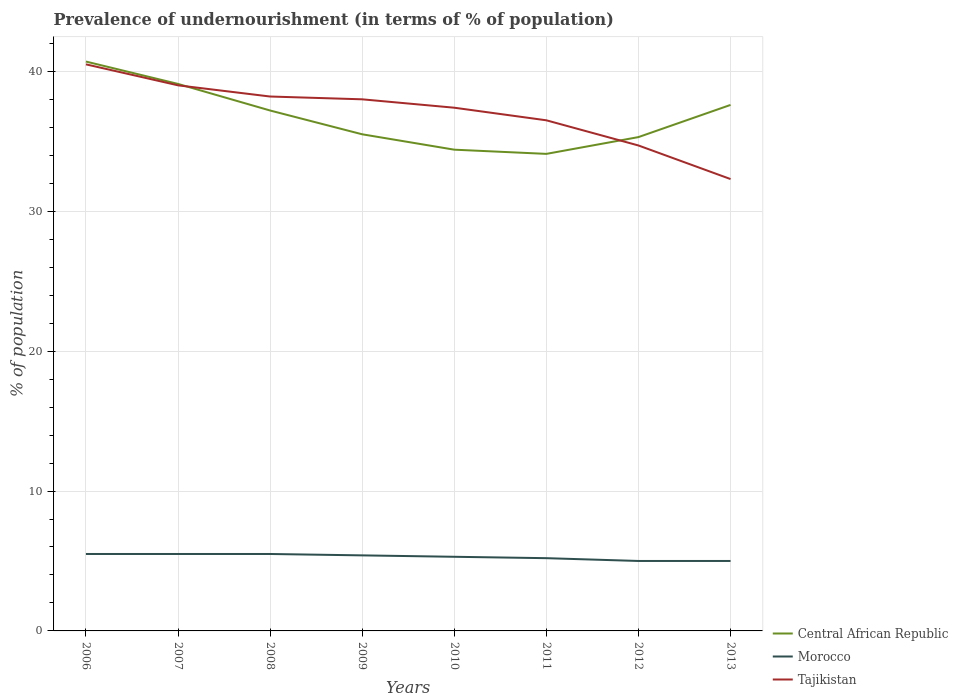What is the total percentage of undernourished population in Tajikistan in the graph?
Your response must be concise. 2.5. What is the difference between the highest and the second highest percentage of undernourished population in Central African Republic?
Offer a terse response. 6.6. What is the difference between the highest and the lowest percentage of undernourished population in Central African Republic?
Your response must be concise. 4. How many lines are there?
Provide a succinct answer. 3. How many years are there in the graph?
Offer a very short reply. 8. Are the values on the major ticks of Y-axis written in scientific E-notation?
Give a very brief answer. No. Where does the legend appear in the graph?
Offer a terse response. Bottom right. How many legend labels are there?
Your response must be concise. 3. How are the legend labels stacked?
Ensure brevity in your answer.  Vertical. What is the title of the graph?
Your answer should be compact. Prevalence of undernourishment (in terms of % of population). Does "Sudan" appear as one of the legend labels in the graph?
Your answer should be compact. No. What is the label or title of the X-axis?
Your answer should be compact. Years. What is the label or title of the Y-axis?
Your answer should be very brief. % of population. What is the % of population of Central African Republic in 2006?
Offer a terse response. 40.7. What is the % of population of Morocco in 2006?
Your answer should be very brief. 5.5. What is the % of population in Tajikistan in 2006?
Offer a terse response. 40.5. What is the % of population of Central African Republic in 2007?
Provide a succinct answer. 39.1. What is the % of population of Morocco in 2007?
Offer a very short reply. 5.5. What is the % of population in Tajikistan in 2007?
Give a very brief answer. 39. What is the % of population in Central African Republic in 2008?
Ensure brevity in your answer.  37.2. What is the % of population of Morocco in 2008?
Offer a very short reply. 5.5. What is the % of population in Tajikistan in 2008?
Make the answer very short. 38.2. What is the % of population in Central African Republic in 2009?
Your response must be concise. 35.5. What is the % of population of Morocco in 2009?
Keep it short and to the point. 5.4. What is the % of population of Central African Republic in 2010?
Keep it short and to the point. 34.4. What is the % of population in Tajikistan in 2010?
Your response must be concise. 37.4. What is the % of population of Central African Republic in 2011?
Provide a succinct answer. 34.1. What is the % of population of Tajikistan in 2011?
Your answer should be compact. 36.5. What is the % of population in Central African Republic in 2012?
Ensure brevity in your answer.  35.3. What is the % of population in Morocco in 2012?
Your response must be concise. 5. What is the % of population in Tajikistan in 2012?
Ensure brevity in your answer.  34.7. What is the % of population of Central African Republic in 2013?
Your answer should be compact. 37.6. What is the % of population of Morocco in 2013?
Your answer should be compact. 5. What is the % of population in Tajikistan in 2013?
Ensure brevity in your answer.  32.3. Across all years, what is the maximum % of population in Central African Republic?
Make the answer very short. 40.7. Across all years, what is the maximum % of population in Morocco?
Give a very brief answer. 5.5. Across all years, what is the maximum % of population in Tajikistan?
Your answer should be very brief. 40.5. Across all years, what is the minimum % of population of Central African Republic?
Keep it short and to the point. 34.1. Across all years, what is the minimum % of population of Morocco?
Offer a terse response. 5. Across all years, what is the minimum % of population in Tajikistan?
Provide a short and direct response. 32.3. What is the total % of population in Central African Republic in the graph?
Provide a succinct answer. 293.9. What is the total % of population of Morocco in the graph?
Give a very brief answer. 42.4. What is the total % of population of Tajikistan in the graph?
Provide a short and direct response. 296.6. What is the difference between the % of population in Central African Republic in 2006 and that in 2007?
Your answer should be very brief. 1.6. What is the difference between the % of population of Central African Republic in 2006 and that in 2008?
Provide a short and direct response. 3.5. What is the difference between the % of population of Morocco in 2006 and that in 2008?
Offer a terse response. 0. What is the difference between the % of population in Tajikistan in 2006 and that in 2008?
Ensure brevity in your answer.  2.3. What is the difference between the % of population of Morocco in 2006 and that in 2010?
Ensure brevity in your answer.  0.2. What is the difference between the % of population of Central African Republic in 2006 and that in 2011?
Provide a short and direct response. 6.6. What is the difference between the % of population of Morocco in 2006 and that in 2011?
Keep it short and to the point. 0.3. What is the difference between the % of population in Tajikistan in 2006 and that in 2011?
Provide a succinct answer. 4. What is the difference between the % of population in Central African Republic in 2006 and that in 2012?
Your answer should be very brief. 5.4. What is the difference between the % of population of Tajikistan in 2006 and that in 2012?
Your response must be concise. 5.8. What is the difference between the % of population in Morocco in 2006 and that in 2013?
Keep it short and to the point. 0.5. What is the difference between the % of population of Tajikistan in 2006 and that in 2013?
Ensure brevity in your answer.  8.2. What is the difference between the % of population of Central African Republic in 2007 and that in 2008?
Give a very brief answer. 1.9. What is the difference between the % of population in Morocco in 2007 and that in 2008?
Make the answer very short. 0. What is the difference between the % of population of Tajikistan in 2007 and that in 2008?
Ensure brevity in your answer.  0.8. What is the difference between the % of population in Central African Republic in 2007 and that in 2009?
Offer a very short reply. 3.6. What is the difference between the % of population of Morocco in 2007 and that in 2009?
Keep it short and to the point. 0.1. What is the difference between the % of population of Tajikistan in 2007 and that in 2009?
Your answer should be very brief. 1. What is the difference between the % of population of Morocco in 2007 and that in 2010?
Ensure brevity in your answer.  0.2. What is the difference between the % of population of Tajikistan in 2007 and that in 2010?
Your answer should be very brief. 1.6. What is the difference between the % of population of Central African Republic in 2007 and that in 2012?
Your answer should be very brief. 3.8. What is the difference between the % of population of Tajikistan in 2007 and that in 2013?
Ensure brevity in your answer.  6.7. What is the difference between the % of population of Central African Republic in 2008 and that in 2009?
Ensure brevity in your answer.  1.7. What is the difference between the % of population of Tajikistan in 2008 and that in 2009?
Your response must be concise. 0.2. What is the difference between the % of population in Central African Republic in 2008 and that in 2010?
Offer a terse response. 2.8. What is the difference between the % of population of Morocco in 2008 and that in 2010?
Offer a very short reply. 0.2. What is the difference between the % of population of Tajikistan in 2008 and that in 2011?
Your answer should be compact. 1.7. What is the difference between the % of population in Central African Republic in 2008 and that in 2012?
Your answer should be compact. 1.9. What is the difference between the % of population in Morocco in 2008 and that in 2012?
Your answer should be very brief. 0.5. What is the difference between the % of population of Central African Republic in 2009 and that in 2010?
Your answer should be very brief. 1.1. What is the difference between the % of population of Tajikistan in 2009 and that in 2010?
Offer a very short reply. 0.6. What is the difference between the % of population in Central African Republic in 2009 and that in 2011?
Provide a succinct answer. 1.4. What is the difference between the % of population of Morocco in 2009 and that in 2011?
Provide a succinct answer. 0.2. What is the difference between the % of population of Tajikistan in 2009 and that in 2011?
Provide a short and direct response. 1.5. What is the difference between the % of population of Morocco in 2009 and that in 2013?
Offer a terse response. 0.4. What is the difference between the % of population in Tajikistan in 2009 and that in 2013?
Your answer should be compact. 5.7. What is the difference between the % of population of Central African Republic in 2010 and that in 2012?
Give a very brief answer. -0.9. What is the difference between the % of population in Morocco in 2010 and that in 2012?
Make the answer very short. 0.3. What is the difference between the % of population in Central African Republic in 2010 and that in 2013?
Your response must be concise. -3.2. What is the difference between the % of population of Tajikistan in 2010 and that in 2013?
Your answer should be compact. 5.1. What is the difference between the % of population of Central African Republic in 2011 and that in 2012?
Keep it short and to the point. -1.2. What is the difference between the % of population of Central African Republic in 2011 and that in 2013?
Your answer should be compact. -3.5. What is the difference between the % of population of Morocco in 2011 and that in 2013?
Your response must be concise. 0.2. What is the difference between the % of population in Tajikistan in 2011 and that in 2013?
Your response must be concise. 4.2. What is the difference between the % of population of Central African Republic in 2012 and that in 2013?
Your response must be concise. -2.3. What is the difference between the % of population in Morocco in 2012 and that in 2013?
Give a very brief answer. 0. What is the difference between the % of population in Central African Republic in 2006 and the % of population in Morocco in 2007?
Provide a short and direct response. 35.2. What is the difference between the % of population of Central African Republic in 2006 and the % of population of Tajikistan in 2007?
Offer a terse response. 1.7. What is the difference between the % of population in Morocco in 2006 and the % of population in Tajikistan in 2007?
Offer a very short reply. -33.5. What is the difference between the % of population in Central African Republic in 2006 and the % of population in Morocco in 2008?
Provide a short and direct response. 35.2. What is the difference between the % of population of Morocco in 2006 and the % of population of Tajikistan in 2008?
Ensure brevity in your answer.  -32.7. What is the difference between the % of population of Central African Republic in 2006 and the % of population of Morocco in 2009?
Your answer should be compact. 35.3. What is the difference between the % of population of Central African Republic in 2006 and the % of population of Tajikistan in 2009?
Offer a very short reply. 2.7. What is the difference between the % of population of Morocco in 2006 and the % of population of Tajikistan in 2009?
Make the answer very short. -32.5. What is the difference between the % of population in Central African Republic in 2006 and the % of population in Morocco in 2010?
Your answer should be very brief. 35.4. What is the difference between the % of population of Central African Republic in 2006 and the % of population of Tajikistan in 2010?
Make the answer very short. 3.3. What is the difference between the % of population in Morocco in 2006 and the % of population in Tajikistan in 2010?
Keep it short and to the point. -31.9. What is the difference between the % of population in Central African Republic in 2006 and the % of population in Morocco in 2011?
Your answer should be compact. 35.5. What is the difference between the % of population in Morocco in 2006 and the % of population in Tajikistan in 2011?
Offer a terse response. -31. What is the difference between the % of population in Central African Republic in 2006 and the % of population in Morocco in 2012?
Your answer should be compact. 35.7. What is the difference between the % of population of Morocco in 2006 and the % of population of Tajikistan in 2012?
Provide a short and direct response. -29.2. What is the difference between the % of population of Central African Republic in 2006 and the % of population of Morocco in 2013?
Ensure brevity in your answer.  35.7. What is the difference between the % of population of Central African Republic in 2006 and the % of population of Tajikistan in 2013?
Offer a very short reply. 8.4. What is the difference between the % of population in Morocco in 2006 and the % of population in Tajikistan in 2013?
Offer a terse response. -26.8. What is the difference between the % of population of Central African Republic in 2007 and the % of population of Morocco in 2008?
Keep it short and to the point. 33.6. What is the difference between the % of population of Morocco in 2007 and the % of population of Tajikistan in 2008?
Provide a succinct answer. -32.7. What is the difference between the % of population in Central African Republic in 2007 and the % of population in Morocco in 2009?
Offer a very short reply. 33.7. What is the difference between the % of population in Central African Republic in 2007 and the % of population in Tajikistan in 2009?
Offer a very short reply. 1.1. What is the difference between the % of population of Morocco in 2007 and the % of population of Tajikistan in 2009?
Provide a succinct answer. -32.5. What is the difference between the % of population in Central African Republic in 2007 and the % of population in Morocco in 2010?
Your answer should be compact. 33.8. What is the difference between the % of population of Central African Republic in 2007 and the % of population of Tajikistan in 2010?
Provide a succinct answer. 1.7. What is the difference between the % of population of Morocco in 2007 and the % of population of Tajikistan in 2010?
Give a very brief answer. -31.9. What is the difference between the % of population of Central African Republic in 2007 and the % of population of Morocco in 2011?
Your answer should be compact. 33.9. What is the difference between the % of population of Central African Republic in 2007 and the % of population of Tajikistan in 2011?
Offer a very short reply. 2.6. What is the difference between the % of population of Morocco in 2007 and the % of population of Tajikistan in 2011?
Provide a succinct answer. -31. What is the difference between the % of population in Central African Republic in 2007 and the % of population in Morocco in 2012?
Provide a succinct answer. 34.1. What is the difference between the % of population in Morocco in 2007 and the % of population in Tajikistan in 2012?
Give a very brief answer. -29.2. What is the difference between the % of population of Central African Republic in 2007 and the % of population of Morocco in 2013?
Your answer should be compact. 34.1. What is the difference between the % of population in Central African Republic in 2007 and the % of population in Tajikistan in 2013?
Provide a short and direct response. 6.8. What is the difference between the % of population in Morocco in 2007 and the % of population in Tajikistan in 2013?
Your answer should be very brief. -26.8. What is the difference between the % of population in Central African Republic in 2008 and the % of population in Morocco in 2009?
Your answer should be compact. 31.8. What is the difference between the % of population of Central African Republic in 2008 and the % of population of Tajikistan in 2009?
Provide a short and direct response. -0.8. What is the difference between the % of population of Morocco in 2008 and the % of population of Tajikistan in 2009?
Give a very brief answer. -32.5. What is the difference between the % of population of Central African Republic in 2008 and the % of population of Morocco in 2010?
Offer a very short reply. 31.9. What is the difference between the % of population in Central African Republic in 2008 and the % of population in Tajikistan in 2010?
Give a very brief answer. -0.2. What is the difference between the % of population of Morocco in 2008 and the % of population of Tajikistan in 2010?
Ensure brevity in your answer.  -31.9. What is the difference between the % of population in Morocco in 2008 and the % of population in Tajikistan in 2011?
Provide a short and direct response. -31. What is the difference between the % of population in Central African Republic in 2008 and the % of population in Morocco in 2012?
Keep it short and to the point. 32.2. What is the difference between the % of population in Central African Republic in 2008 and the % of population in Tajikistan in 2012?
Offer a very short reply. 2.5. What is the difference between the % of population in Morocco in 2008 and the % of population in Tajikistan in 2012?
Provide a short and direct response. -29.2. What is the difference between the % of population in Central African Republic in 2008 and the % of population in Morocco in 2013?
Your answer should be very brief. 32.2. What is the difference between the % of population in Morocco in 2008 and the % of population in Tajikistan in 2013?
Give a very brief answer. -26.8. What is the difference between the % of population in Central African Republic in 2009 and the % of population in Morocco in 2010?
Offer a terse response. 30.2. What is the difference between the % of population in Central African Republic in 2009 and the % of population in Tajikistan in 2010?
Offer a terse response. -1.9. What is the difference between the % of population of Morocco in 2009 and the % of population of Tajikistan in 2010?
Your answer should be very brief. -32. What is the difference between the % of population of Central African Republic in 2009 and the % of population of Morocco in 2011?
Your answer should be very brief. 30.3. What is the difference between the % of population in Morocco in 2009 and the % of population in Tajikistan in 2011?
Provide a succinct answer. -31.1. What is the difference between the % of population in Central African Republic in 2009 and the % of population in Morocco in 2012?
Keep it short and to the point. 30.5. What is the difference between the % of population of Morocco in 2009 and the % of population of Tajikistan in 2012?
Your answer should be very brief. -29.3. What is the difference between the % of population of Central African Republic in 2009 and the % of population of Morocco in 2013?
Your response must be concise. 30.5. What is the difference between the % of population in Morocco in 2009 and the % of population in Tajikistan in 2013?
Your answer should be very brief. -26.9. What is the difference between the % of population in Central African Republic in 2010 and the % of population in Morocco in 2011?
Ensure brevity in your answer.  29.2. What is the difference between the % of population in Morocco in 2010 and the % of population in Tajikistan in 2011?
Keep it short and to the point. -31.2. What is the difference between the % of population in Central African Republic in 2010 and the % of population in Morocco in 2012?
Provide a short and direct response. 29.4. What is the difference between the % of population in Central African Republic in 2010 and the % of population in Tajikistan in 2012?
Make the answer very short. -0.3. What is the difference between the % of population of Morocco in 2010 and the % of population of Tajikistan in 2012?
Give a very brief answer. -29.4. What is the difference between the % of population of Central African Republic in 2010 and the % of population of Morocco in 2013?
Your answer should be compact. 29.4. What is the difference between the % of population in Central African Republic in 2011 and the % of population in Morocco in 2012?
Ensure brevity in your answer.  29.1. What is the difference between the % of population in Morocco in 2011 and the % of population in Tajikistan in 2012?
Offer a terse response. -29.5. What is the difference between the % of population in Central African Republic in 2011 and the % of population in Morocco in 2013?
Give a very brief answer. 29.1. What is the difference between the % of population in Central African Republic in 2011 and the % of population in Tajikistan in 2013?
Keep it short and to the point. 1.8. What is the difference between the % of population in Morocco in 2011 and the % of population in Tajikistan in 2013?
Offer a terse response. -27.1. What is the difference between the % of population of Central African Republic in 2012 and the % of population of Morocco in 2013?
Your answer should be compact. 30.3. What is the difference between the % of population of Central African Republic in 2012 and the % of population of Tajikistan in 2013?
Provide a succinct answer. 3. What is the difference between the % of population in Morocco in 2012 and the % of population in Tajikistan in 2013?
Your answer should be very brief. -27.3. What is the average % of population in Central African Republic per year?
Ensure brevity in your answer.  36.74. What is the average % of population in Tajikistan per year?
Your response must be concise. 37.08. In the year 2006, what is the difference between the % of population of Central African Republic and % of population of Morocco?
Provide a succinct answer. 35.2. In the year 2006, what is the difference between the % of population of Morocco and % of population of Tajikistan?
Provide a succinct answer. -35. In the year 2007, what is the difference between the % of population of Central African Republic and % of population of Morocco?
Your answer should be compact. 33.6. In the year 2007, what is the difference between the % of population in Morocco and % of population in Tajikistan?
Provide a short and direct response. -33.5. In the year 2008, what is the difference between the % of population of Central African Republic and % of population of Morocco?
Offer a terse response. 31.7. In the year 2008, what is the difference between the % of population of Morocco and % of population of Tajikistan?
Offer a terse response. -32.7. In the year 2009, what is the difference between the % of population in Central African Republic and % of population in Morocco?
Make the answer very short. 30.1. In the year 2009, what is the difference between the % of population in Central African Republic and % of population in Tajikistan?
Your response must be concise. -2.5. In the year 2009, what is the difference between the % of population of Morocco and % of population of Tajikistan?
Make the answer very short. -32.6. In the year 2010, what is the difference between the % of population in Central African Republic and % of population in Morocco?
Your answer should be very brief. 29.1. In the year 2010, what is the difference between the % of population of Central African Republic and % of population of Tajikistan?
Ensure brevity in your answer.  -3. In the year 2010, what is the difference between the % of population of Morocco and % of population of Tajikistan?
Your response must be concise. -32.1. In the year 2011, what is the difference between the % of population of Central African Republic and % of population of Morocco?
Provide a short and direct response. 28.9. In the year 2011, what is the difference between the % of population of Central African Republic and % of population of Tajikistan?
Offer a very short reply. -2.4. In the year 2011, what is the difference between the % of population in Morocco and % of population in Tajikistan?
Your answer should be compact. -31.3. In the year 2012, what is the difference between the % of population of Central African Republic and % of population of Morocco?
Make the answer very short. 30.3. In the year 2012, what is the difference between the % of population of Morocco and % of population of Tajikistan?
Ensure brevity in your answer.  -29.7. In the year 2013, what is the difference between the % of population in Central African Republic and % of population in Morocco?
Make the answer very short. 32.6. In the year 2013, what is the difference between the % of population in Morocco and % of population in Tajikistan?
Offer a terse response. -27.3. What is the ratio of the % of population of Central African Republic in 2006 to that in 2007?
Your response must be concise. 1.04. What is the ratio of the % of population of Tajikistan in 2006 to that in 2007?
Make the answer very short. 1.04. What is the ratio of the % of population of Central African Republic in 2006 to that in 2008?
Offer a very short reply. 1.09. What is the ratio of the % of population in Tajikistan in 2006 to that in 2008?
Provide a succinct answer. 1.06. What is the ratio of the % of population of Central African Republic in 2006 to that in 2009?
Offer a terse response. 1.15. What is the ratio of the % of population in Morocco in 2006 to that in 2009?
Ensure brevity in your answer.  1.02. What is the ratio of the % of population in Tajikistan in 2006 to that in 2009?
Provide a short and direct response. 1.07. What is the ratio of the % of population in Central African Republic in 2006 to that in 2010?
Provide a succinct answer. 1.18. What is the ratio of the % of population of Morocco in 2006 to that in 2010?
Ensure brevity in your answer.  1.04. What is the ratio of the % of population in Tajikistan in 2006 to that in 2010?
Your response must be concise. 1.08. What is the ratio of the % of population of Central African Republic in 2006 to that in 2011?
Provide a succinct answer. 1.19. What is the ratio of the % of population in Morocco in 2006 to that in 2011?
Provide a short and direct response. 1.06. What is the ratio of the % of population in Tajikistan in 2006 to that in 2011?
Provide a short and direct response. 1.11. What is the ratio of the % of population of Central African Republic in 2006 to that in 2012?
Make the answer very short. 1.15. What is the ratio of the % of population of Tajikistan in 2006 to that in 2012?
Provide a succinct answer. 1.17. What is the ratio of the % of population of Central African Republic in 2006 to that in 2013?
Provide a short and direct response. 1.08. What is the ratio of the % of population in Morocco in 2006 to that in 2013?
Make the answer very short. 1.1. What is the ratio of the % of population of Tajikistan in 2006 to that in 2013?
Provide a short and direct response. 1.25. What is the ratio of the % of population of Central African Republic in 2007 to that in 2008?
Give a very brief answer. 1.05. What is the ratio of the % of population in Morocco in 2007 to that in 2008?
Keep it short and to the point. 1. What is the ratio of the % of population in Tajikistan in 2007 to that in 2008?
Ensure brevity in your answer.  1.02. What is the ratio of the % of population of Central African Republic in 2007 to that in 2009?
Provide a short and direct response. 1.1. What is the ratio of the % of population of Morocco in 2007 to that in 2009?
Your answer should be compact. 1.02. What is the ratio of the % of population in Tajikistan in 2007 to that in 2009?
Give a very brief answer. 1.03. What is the ratio of the % of population in Central African Republic in 2007 to that in 2010?
Make the answer very short. 1.14. What is the ratio of the % of population of Morocco in 2007 to that in 2010?
Give a very brief answer. 1.04. What is the ratio of the % of population in Tajikistan in 2007 to that in 2010?
Provide a short and direct response. 1.04. What is the ratio of the % of population of Central African Republic in 2007 to that in 2011?
Offer a very short reply. 1.15. What is the ratio of the % of population in Morocco in 2007 to that in 2011?
Your response must be concise. 1.06. What is the ratio of the % of population of Tajikistan in 2007 to that in 2011?
Your answer should be compact. 1.07. What is the ratio of the % of population of Central African Republic in 2007 to that in 2012?
Provide a succinct answer. 1.11. What is the ratio of the % of population in Morocco in 2007 to that in 2012?
Ensure brevity in your answer.  1.1. What is the ratio of the % of population in Tajikistan in 2007 to that in 2012?
Your answer should be very brief. 1.12. What is the ratio of the % of population of Central African Republic in 2007 to that in 2013?
Offer a very short reply. 1.04. What is the ratio of the % of population in Tajikistan in 2007 to that in 2013?
Offer a very short reply. 1.21. What is the ratio of the % of population of Central African Republic in 2008 to that in 2009?
Give a very brief answer. 1.05. What is the ratio of the % of population in Morocco in 2008 to that in 2009?
Your answer should be very brief. 1.02. What is the ratio of the % of population in Central African Republic in 2008 to that in 2010?
Offer a very short reply. 1.08. What is the ratio of the % of population of Morocco in 2008 to that in 2010?
Provide a short and direct response. 1.04. What is the ratio of the % of population in Tajikistan in 2008 to that in 2010?
Ensure brevity in your answer.  1.02. What is the ratio of the % of population in Central African Republic in 2008 to that in 2011?
Keep it short and to the point. 1.09. What is the ratio of the % of population in Morocco in 2008 to that in 2011?
Keep it short and to the point. 1.06. What is the ratio of the % of population of Tajikistan in 2008 to that in 2011?
Your response must be concise. 1.05. What is the ratio of the % of population of Central African Republic in 2008 to that in 2012?
Make the answer very short. 1.05. What is the ratio of the % of population of Tajikistan in 2008 to that in 2012?
Keep it short and to the point. 1.1. What is the ratio of the % of population in Central African Republic in 2008 to that in 2013?
Offer a terse response. 0.99. What is the ratio of the % of population of Morocco in 2008 to that in 2013?
Make the answer very short. 1.1. What is the ratio of the % of population of Tajikistan in 2008 to that in 2013?
Offer a very short reply. 1.18. What is the ratio of the % of population of Central African Republic in 2009 to that in 2010?
Your answer should be compact. 1.03. What is the ratio of the % of population in Morocco in 2009 to that in 2010?
Offer a very short reply. 1.02. What is the ratio of the % of population of Tajikistan in 2009 to that in 2010?
Your answer should be very brief. 1.02. What is the ratio of the % of population in Central African Republic in 2009 to that in 2011?
Provide a short and direct response. 1.04. What is the ratio of the % of population in Morocco in 2009 to that in 2011?
Keep it short and to the point. 1.04. What is the ratio of the % of population of Tajikistan in 2009 to that in 2011?
Your response must be concise. 1.04. What is the ratio of the % of population in Central African Republic in 2009 to that in 2012?
Provide a succinct answer. 1.01. What is the ratio of the % of population of Tajikistan in 2009 to that in 2012?
Make the answer very short. 1.1. What is the ratio of the % of population of Central African Republic in 2009 to that in 2013?
Give a very brief answer. 0.94. What is the ratio of the % of population of Morocco in 2009 to that in 2013?
Provide a short and direct response. 1.08. What is the ratio of the % of population in Tajikistan in 2009 to that in 2013?
Offer a terse response. 1.18. What is the ratio of the % of population of Central African Republic in 2010 to that in 2011?
Your answer should be compact. 1.01. What is the ratio of the % of population in Morocco in 2010 to that in 2011?
Make the answer very short. 1.02. What is the ratio of the % of population in Tajikistan in 2010 to that in 2011?
Ensure brevity in your answer.  1.02. What is the ratio of the % of population of Central African Republic in 2010 to that in 2012?
Keep it short and to the point. 0.97. What is the ratio of the % of population of Morocco in 2010 to that in 2012?
Offer a very short reply. 1.06. What is the ratio of the % of population of Tajikistan in 2010 to that in 2012?
Your response must be concise. 1.08. What is the ratio of the % of population in Central African Republic in 2010 to that in 2013?
Give a very brief answer. 0.91. What is the ratio of the % of population of Morocco in 2010 to that in 2013?
Make the answer very short. 1.06. What is the ratio of the % of population in Tajikistan in 2010 to that in 2013?
Your answer should be very brief. 1.16. What is the ratio of the % of population of Central African Republic in 2011 to that in 2012?
Your response must be concise. 0.97. What is the ratio of the % of population of Tajikistan in 2011 to that in 2012?
Make the answer very short. 1.05. What is the ratio of the % of population in Central African Republic in 2011 to that in 2013?
Keep it short and to the point. 0.91. What is the ratio of the % of population in Tajikistan in 2011 to that in 2013?
Give a very brief answer. 1.13. What is the ratio of the % of population of Central African Republic in 2012 to that in 2013?
Your answer should be compact. 0.94. What is the ratio of the % of population in Morocco in 2012 to that in 2013?
Make the answer very short. 1. What is the ratio of the % of population of Tajikistan in 2012 to that in 2013?
Provide a succinct answer. 1.07. What is the difference between the highest and the second highest % of population in Central African Republic?
Your answer should be compact. 1.6. 